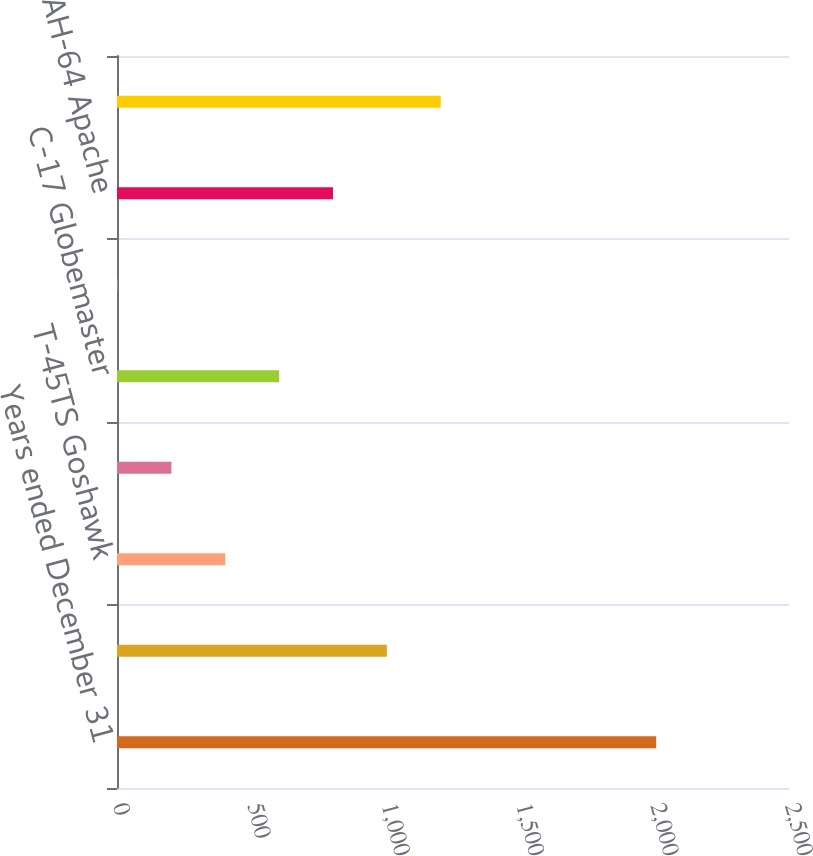<chart> <loc_0><loc_0><loc_500><loc_500><bar_chart><fcel>Years ended December 31<fcel>F/A-18 Models<fcel>T-45TS Goshawk<fcel>F-15E Eagle<fcel>C-17 Globemaster<fcel>CH-47 Chinook<fcel>AH-64 Apache<fcel>Total New-Build Production<nl><fcel>2006<fcel>1004<fcel>402.8<fcel>202.4<fcel>603.2<fcel>2<fcel>803.6<fcel>1204.4<nl></chart> 